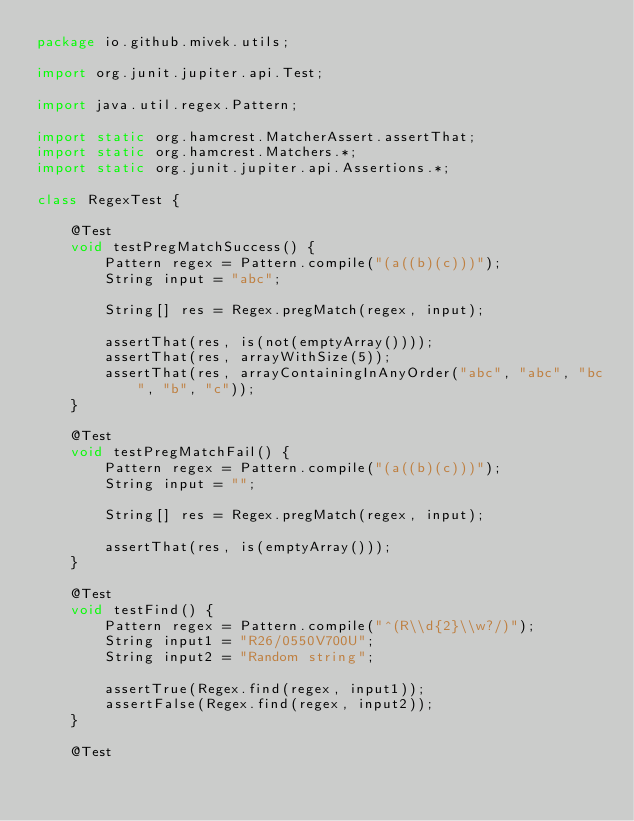Convert code to text. <code><loc_0><loc_0><loc_500><loc_500><_Java_>package io.github.mivek.utils;

import org.junit.jupiter.api.Test;

import java.util.regex.Pattern;

import static org.hamcrest.MatcherAssert.assertThat;
import static org.hamcrest.Matchers.*;
import static org.junit.jupiter.api.Assertions.*;

class RegexTest {

    @Test
    void testPregMatchSuccess() {
        Pattern regex = Pattern.compile("(a((b)(c)))");
        String input = "abc";

        String[] res = Regex.pregMatch(regex, input);

        assertThat(res, is(not(emptyArray())));
        assertThat(res, arrayWithSize(5));
        assertThat(res, arrayContainingInAnyOrder("abc", "abc", "bc", "b", "c"));
    }

    @Test
    void testPregMatchFail() {
        Pattern regex = Pattern.compile("(a((b)(c)))");
        String input = "";

        String[] res = Regex.pregMatch(regex, input);

        assertThat(res, is(emptyArray()));
    }

    @Test
    void testFind() {
        Pattern regex = Pattern.compile("^(R\\d{2}\\w?/)");
        String input1 = "R26/0550V700U";
        String input2 = "Random string";

        assertTrue(Regex.find(regex, input1));
        assertFalse(Regex.find(regex, input2));
    }

    @Test</code> 